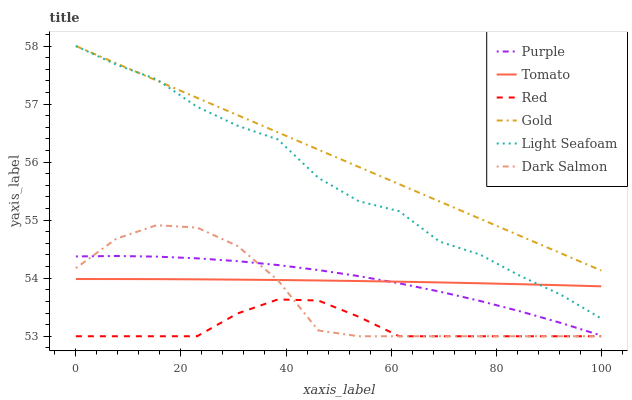Does Purple have the minimum area under the curve?
Answer yes or no. No. Does Purple have the maximum area under the curve?
Answer yes or no. No. Is Purple the smoothest?
Answer yes or no. No. Is Purple the roughest?
Answer yes or no. No. Does Purple have the lowest value?
Answer yes or no. No. Does Purple have the highest value?
Answer yes or no. No. Is Purple less than Gold?
Answer yes or no. Yes. Is Light Seafoam greater than Purple?
Answer yes or no. Yes. Does Purple intersect Gold?
Answer yes or no. No. 